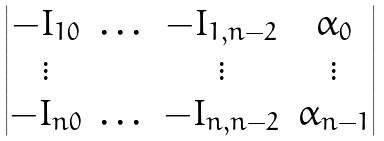<formula> <loc_0><loc_0><loc_500><loc_500>\begin{vmatrix} - I _ { 1 0 } & \dots & - I _ { 1 , n - 2 } & \alpha _ { 0 } \\ \vdots & & \vdots & \vdots \\ - I _ { n 0 } & \dots & - I _ { n , n - 2 } & \alpha _ { n - 1 } \\ \end{vmatrix}</formula> 